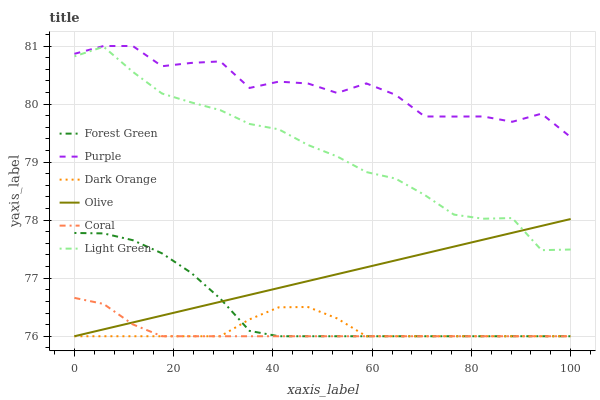Does Coral have the minimum area under the curve?
Answer yes or no. Yes. Does Purple have the maximum area under the curve?
Answer yes or no. Yes. Does Purple have the minimum area under the curve?
Answer yes or no. No. Does Coral have the maximum area under the curve?
Answer yes or no. No. Is Olive the smoothest?
Answer yes or no. Yes. Is Purple the roughest?
Answer yes or no. Yes. Is Coral the smoothest?
Answer yes or no. No. Is Coral the roughest?
Answer yes or no. No. Does Dark Orange have the lowest value?
Answer yes or no. Yes. Does Purple have the lowest value?
Answer yes or no. No. Does Purple have the highest value?
Answer yes or no. Yes. Does Coral have the highest value?
Answer yes or no. No. Is Olive less than Purple?
Answer yes or no. Yes. Is Light Green greater than Dark Orange?
Answer yes or no. Yes. Does Coral intersect Olive?
Answer yes or no. Yes. Is Coral less than Olive?
Answer yes or no. No. Is Coral greater than Olive?
Answer yes or no. No. Does Olive intersect Purple?
Answer yes or no. No. 